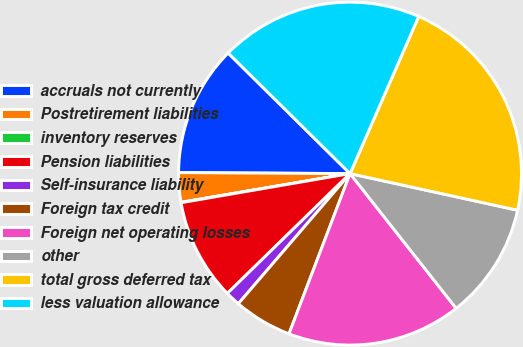<chart> <loc_0><loc_0><loc_500><loc_500><pie_chart><fcel>accruals not currently<fcel>Postretirement liabilities<fcel>inventory reserves<fcel>Pension liabilities<fcel>Self-insurance liability<fcel>Foreign tax credit<fcel>Foreign net operating losses<fcel>other<fcel>total gross deferred tax<fcel>less valuation allowance<nl><fcel>12.32%<fcel>2.77%<fcel>0.04%<fcel>9.59%<fcel>1.4%<fcel>5.5%<fcel>16.41%<fcel>10.96%<fcel>21.87%<fcel>19.14%<nl></chart> 